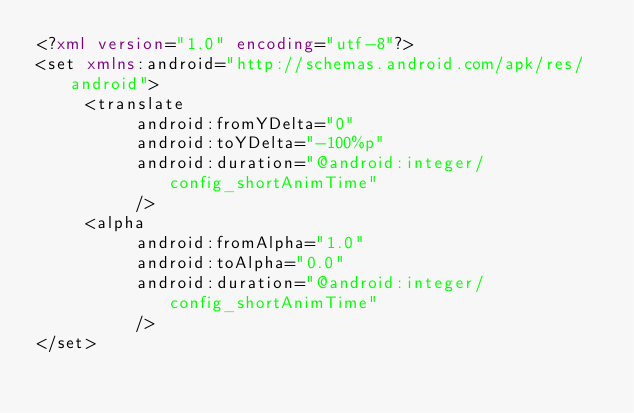Convert code to text. <code><loc_0><loc_0><loc_500><loc_500><_XML_><?xml version="1.0" encoding="utf-8"?>
<set xmlns:android="http://schemas.android.com/apk/res/android">
     <translate
          android:fromYDelta="0"
          android:toYDelta="-100%p"
          android:duration="@android:integer/config_shortAnimTime"
          />
     <alpha
          android:fromAlpha="1.0"
          android:toAlpha="0.0"
          android:duration="@android:integer/config_shortAnimTime"
          />
</set></code> 